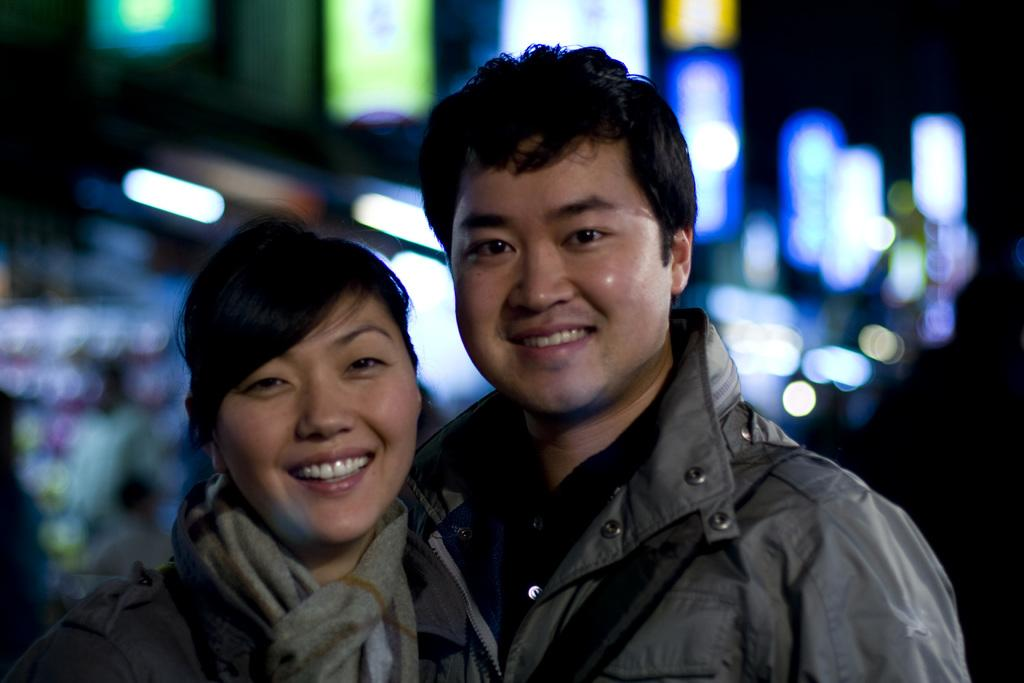How many people are in the image? There are two people in the image, a woman and a man. What are the people in the image wearing? Both the woman and the man are wearing jackets. What expressions do the people in the image have? The woman and the man are smiling in the image. What are the people in the image doing? They are giving a pose for the picture. What can be seen in the background of the image? There are lights visible in the background of the image, and the background is dark. What type of joke is the woman telling in the image? There is no joke being told in the image; the woman and the man are simply smiling and posing for the picture. 